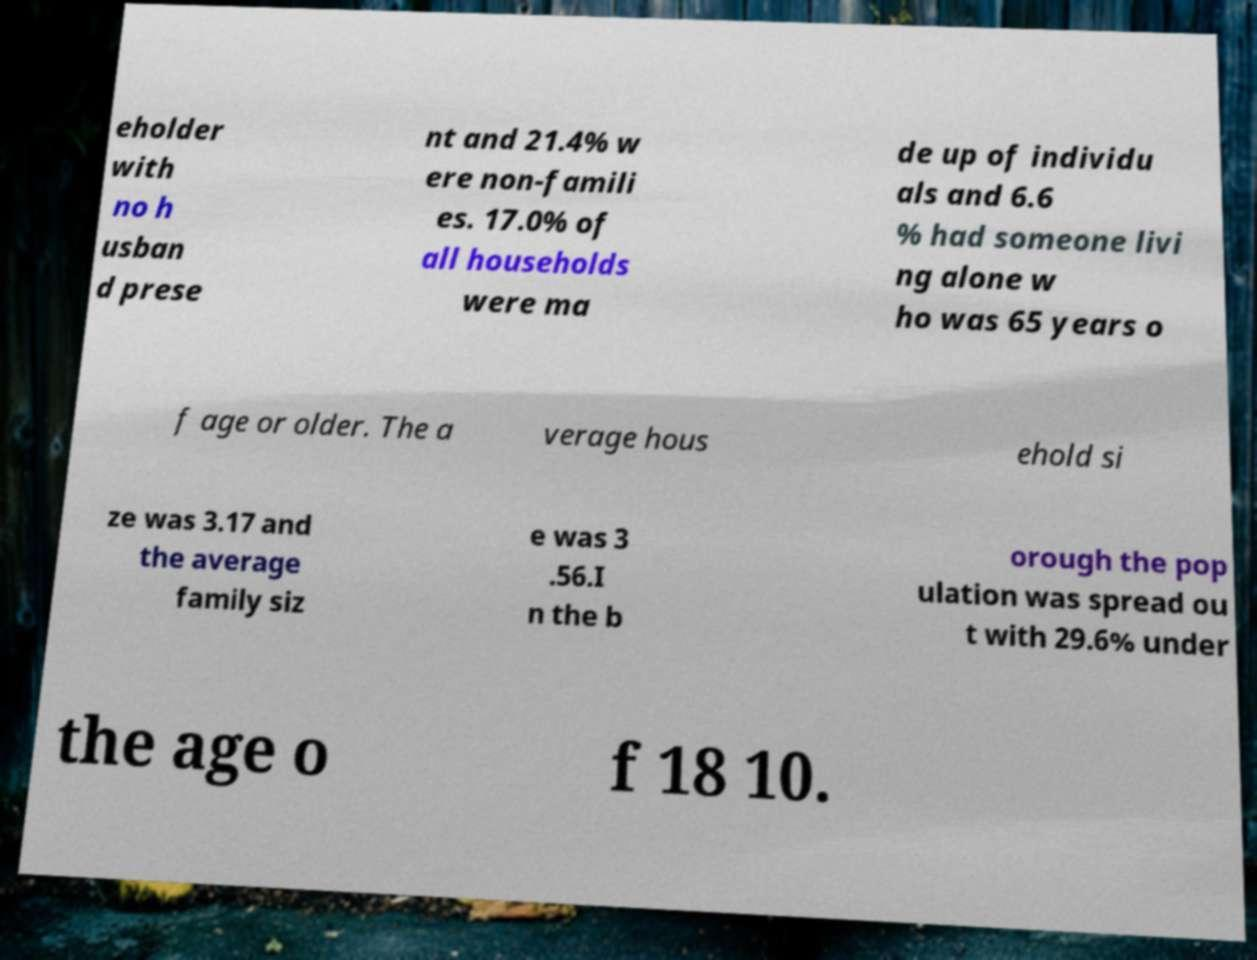Could you extract and type out the text from this image? eholder with no h usban d prese nt and 21.4% w ere non-famili es. 17.0% of all households were ma de up of individu als and 6.6 % had someone livi ng alone w ho was 65 years o f age or older. The a verage hous ehold si ze was 3.17 and the average family siz e was 3 .56.I n the b orough the pop ulation was spread ou t with 29.6% under the age o f 18 10. 